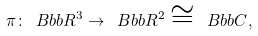Convert formula to latex. <formula><loc_0><loc_0><loc_500><loc_500>\pi \colon { \ B b b R } ^ { 3 } \rightarrow { \ B b b R } ^ { 2 } \cong { \ B b b C } ,</formula> 